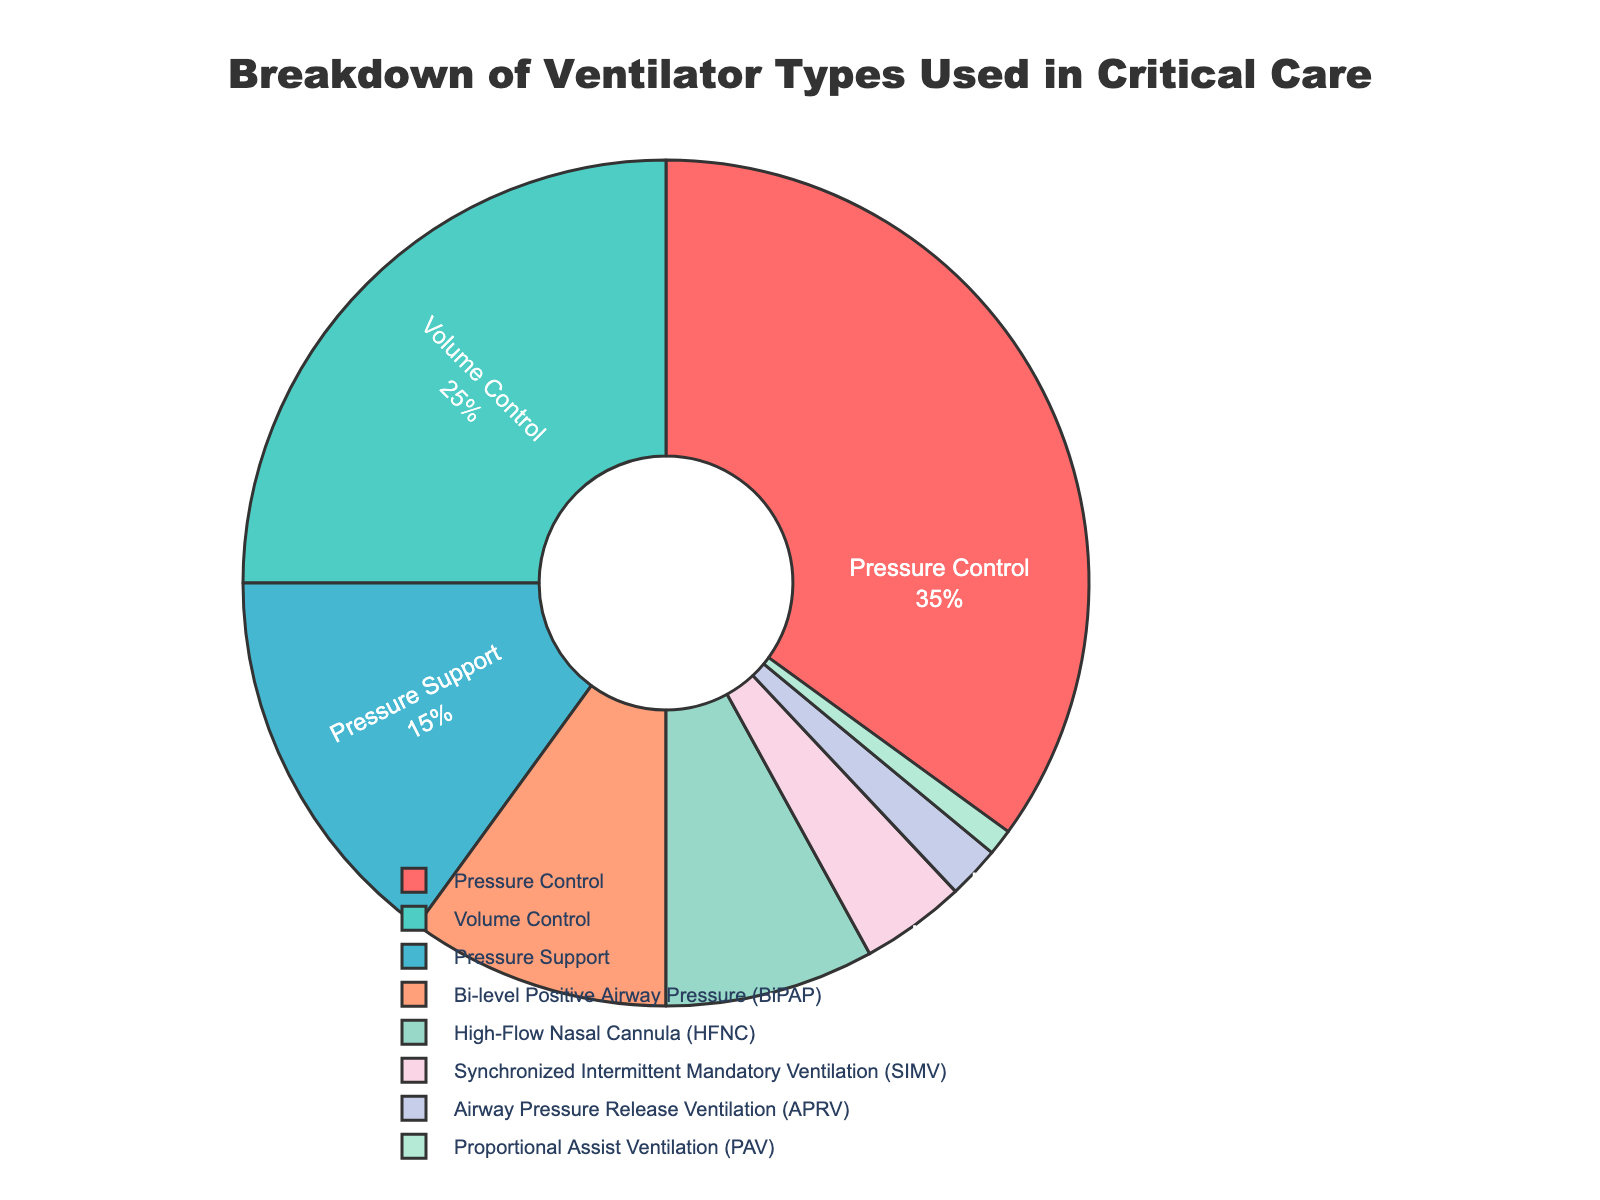How many types of ventilators make up less than 10% individually? By looking at the pie chart, we can count the segments representing each ventilator type that individually account for less than 10%. These are High-Flow Nasal Cannula (8%), Synchronized Intermittent Mandatory Ventilation (4%), Airway Pressure Release Ventilation (2%), and Proportional Assist Ventilation (1%). So, there are 4 types.
Answer: 4 Which ventilator type is represented by the smallest segment? The smallest segment in the pie chart is the one with the smallest percentage, which is Proportional Assist Ventilation with 1%.
Answer: Proportional Assist Ventilation What is the combined percentage of Volume Control and Pressure Support ventilators? To find the combined percentage, add the percentages of Volume Control (25%) and Pressure Support (15%). So, the combined percentage is 25% + 15% = 40%.
Answer: 40% Are there more Pressure Control or Bi-level Positive Airway Pressure (BiPAP) ventilators used? To determine this, compare the segments for Pressure Control (35%) and Bi-level Positive Airway Pressure (BiPAP) (10%). Pressure Control has a larger percentage.
Answer: Pressure Control What is the difference in percentage between the most and least used ventilator types? The most used ventilator type is Pressure Control at 35%, and the least used is Proportional Assist Ventilation at 1%. The difference is 35% - 1% = 34%.
Answer: 34% What proportion of the pie chart is made up by Pressure Control, Volume Control, and Pressure Support ventilators combined? To determine this, add the percentages of Pressure Control (35%), Volume Control (25%), and Pressure Support (15%). The combined percentage is 35% + 25% + 15% = 75%.
Answer: 75% Which ventilator type makes up about one-third of the distribution? Checking the pie chart, Pressure Control contributes 35%, which is approximately one-third of the total distribution.
Answer: Pressure Control How many ventilator types make up more than 20% of the total distribution? By inspecting the chart, we see that only Pressure Control (35%) and Volume Control (25%) are above 20%. So, there are 2 ventilator types.
Answer: 2 